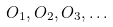Convert formula to latex. <formula><loc_0><loc_0><loc_500><loc_500>O _ { 1 } , O _ { 2 } , O _ { 3 } , \dots</formula> 